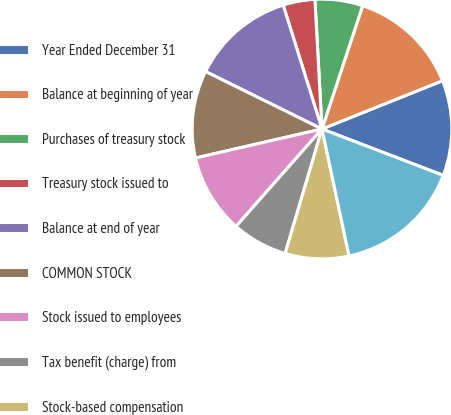<chart> <loc_0><loc_0><loc_500><loc_500><pie_chart><fcel>Year Ended December 31<fcel>Balance at beginning of year<fcel>Purchases of treasury stock<fcel>Treasury stock issued to<fcel>Balance at end of year<fcel>COMMON STOCK<fcel>Stock issued to employees<fcel>Tax benefit (charge) from<fcel>Stock-based compensation<fcel>Net income attributable to<nl><fcel>11.88%<fcel>13.86%<fcel>5.94%<fcel>3.96%<fcel>12.87%<fcel>10.89%<fcel>9.9%<fcel>6.93%<fcel>7.92%<fcel>15.84%<nl></chart> 